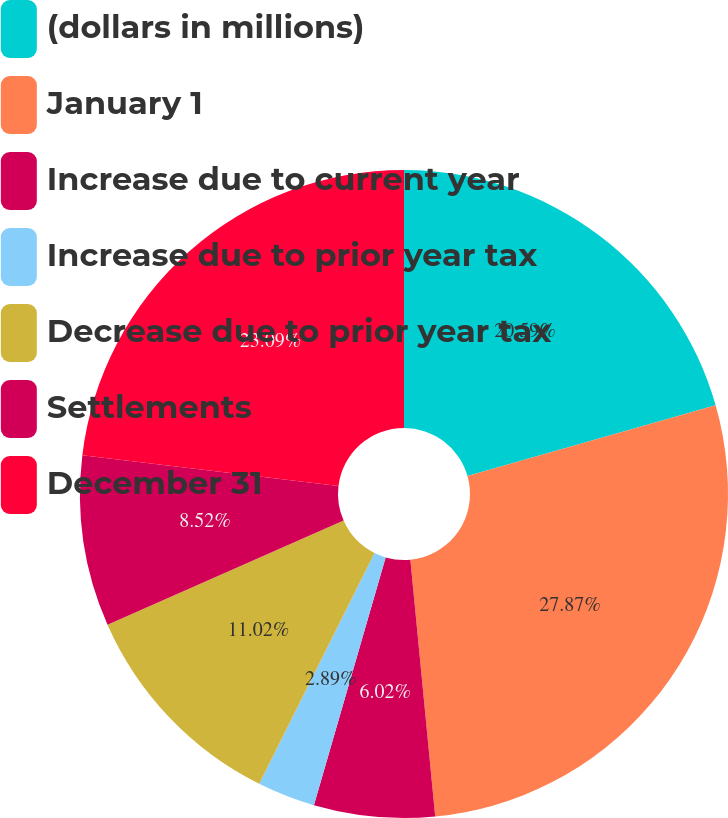Convert chart to OTSL. <chart><loc_0><loc_0><loc_500><loc_500><pie_chart><fcel>(dollars in millions)<fcel>January 1<fcel>Increase due to current year<fcel>Increase due to prior year tax<fcel>Decrease due to prior year tax<fcel>Settlements<fcel>December 31<nl><fcel>20.59%<fcel>27.88%<fcel>6.02%<fcel>2.89%<fcel>11.02%<fcel>8.52%<fcel>23.09%<nl></chart> 